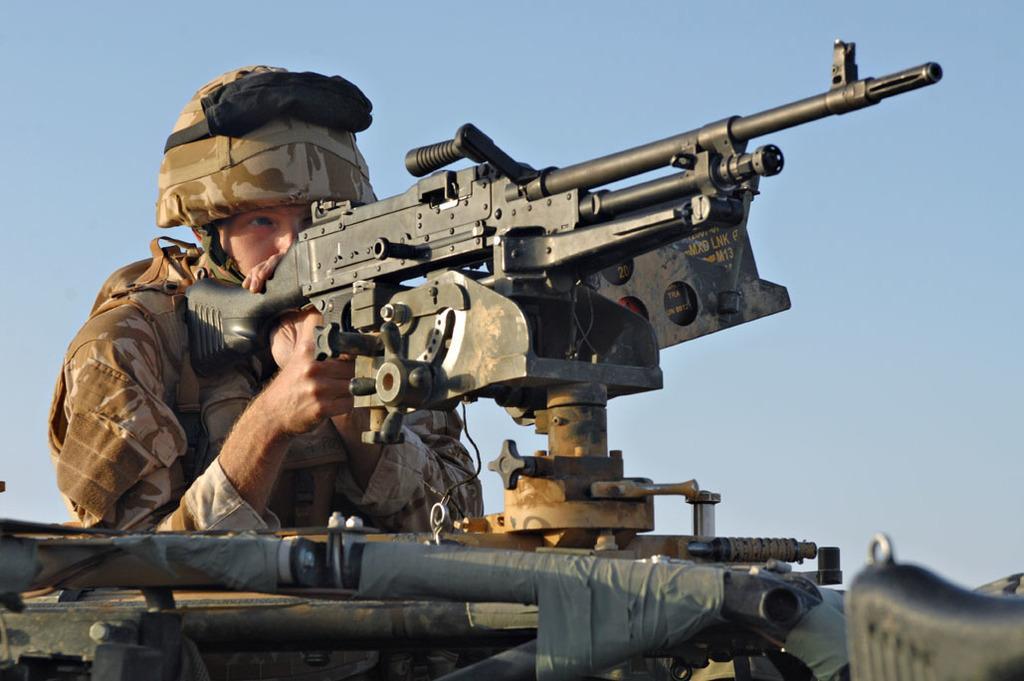Can you describe this image briefly? In the center of the image we can see person holding gun. In the background there is sky. 